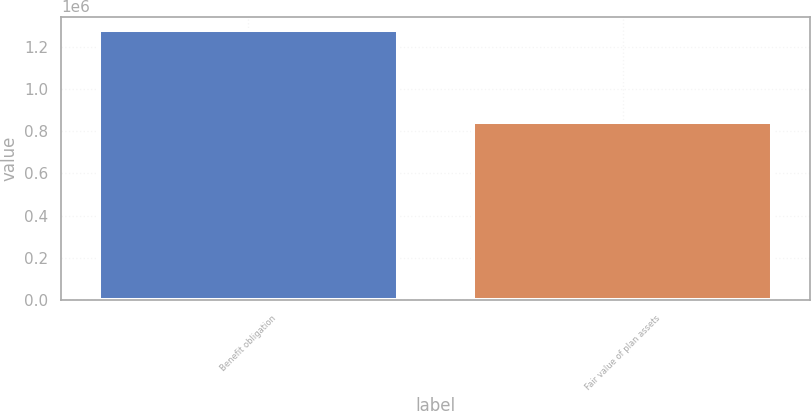<chart> <loc_0><loc_0><loc_500><loc_500><bar_chart><fcel>Benefit obligation<fcel>Fair value of plan assets<nl><fcel>1.27772e+06<fcel>842168<nl></chart> 